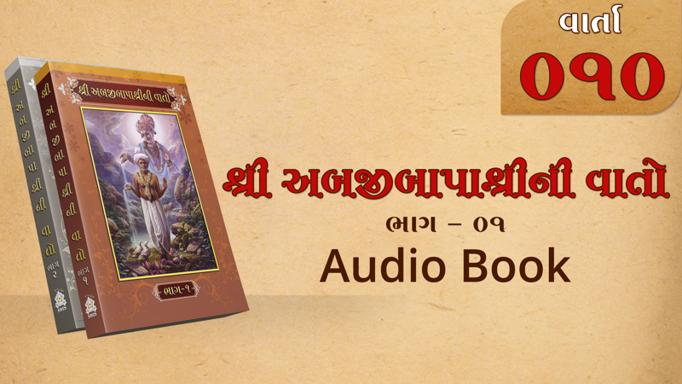What language is the book written in? The book is written in Gujarati, as evidenced by the script on the cover. 